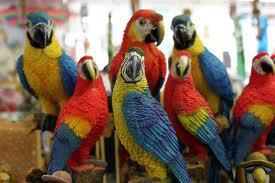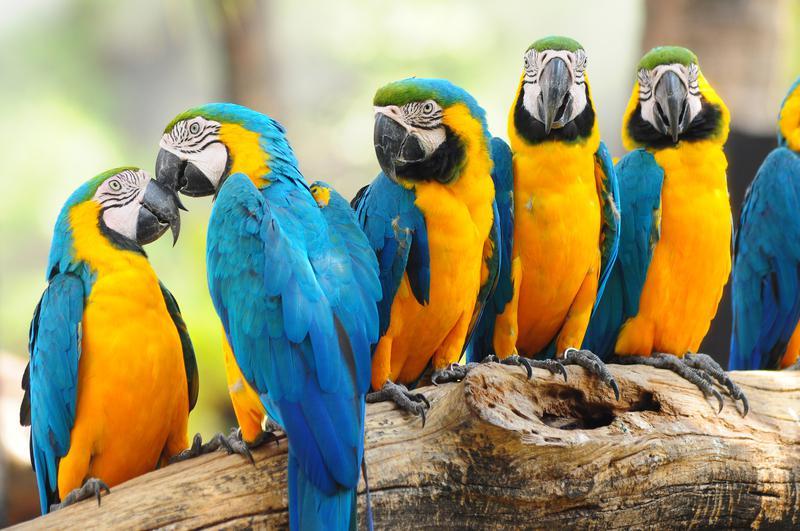The first image is the image on the left, the second image is the image on the right. Analyze the images presented: Is the assertion "The right image shows a row of at least five blue and yellow-orange parrots." valid? Answer yes or no. Yes. 